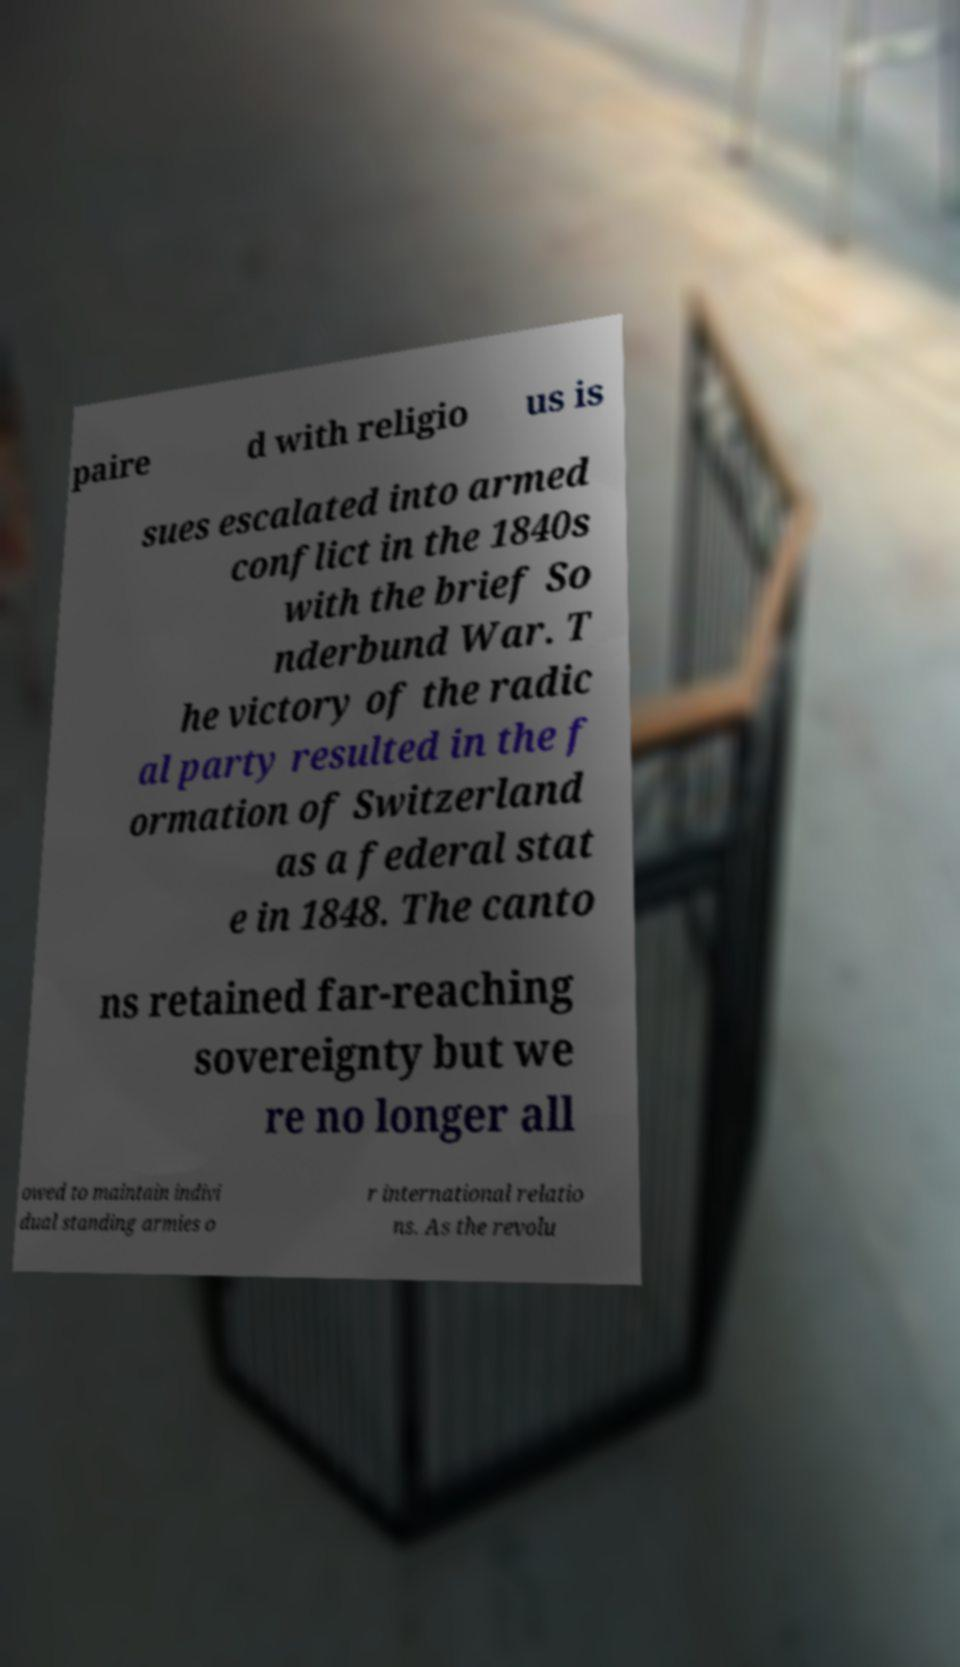What messages or text are displayed in this image? I need them in a readable, typed format. paire d with religio us is sues escalated into armed conflict in the 1840s with the brief So nderbund War. T he victory of the radic al party resulted in the f ormation of Switzerland as a federal stat e in 1848. The canto ns retained far-reaching sovereignty but we re no longer all owed to maintain indivi dual standing armies o r international relatio ns. As the revolu 